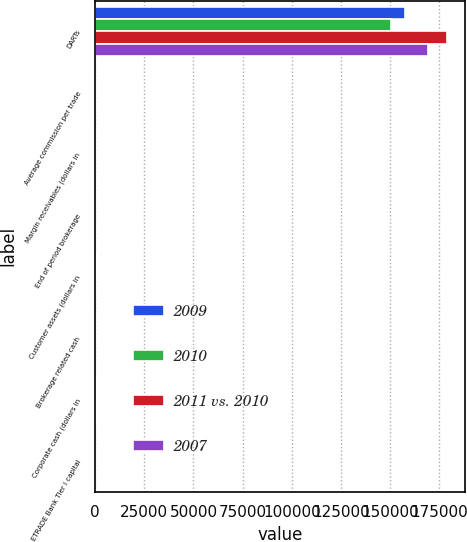Convert chart to OTSL. <chart><loc_0><loc_0><loc_500><loc_500><stacked_bar_chart><ecel><fcel>DARTs<fcel>Average commission per trade<fcel>Margin receivables (dollars in<fcel>End of period brokerage<fcel>Customer assets (dollars in<fcel>Brokerage related cash<fcel>Corporate cash (dollars in<fcel>ETRADE Bank Tier I capital<nl><fcel>2009<fcel>157475<fcel>11.01<fcel>4.8<fcel>22.45<fcel>172.4<fcel>27.7<fcel>484.4<fcel>7.8<nl><fcel>2010<fcel>150532<fcel>11.21<fcel>5.1<fcel>22.45<fcel>176.2<fcel>24.5<fcel>470.5<fcel>7.3<nl><fcel>2011 vs. 2010<fcel>179183<fcel>11.33<fcel>3.7<fcel>22.45<fcel>150.5<fcel>20.4<fcel>393.2<fcel>6.7<nl><fcel>2007<fcel>169075<fcel>10.98<fcel>2.7<fcel>22.45<fcel>110.1<fcel>15.8<fcel>434.9<fcel>6.3<nl></chart> 